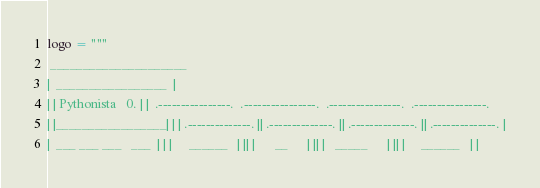Convert code to text. <code><loc_0><loc_0><loc_500><loc_500><_Python_>logo = """
 _____________________
|  _________________  |
| | Pythonista   0. | |  .----------------.  .----------------.  .----------------.  .----------------. 
| |_________________| | | .--------------. || .--------------. || .--------------. || .--------------. |
|  ___ ___ ___   ___  | | |     ______   | || |      __      | || |   _____      | || |     ______   | |</code> 